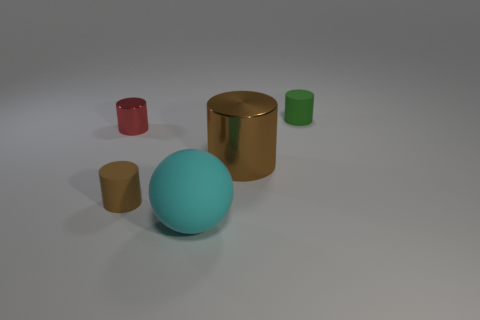Subtract all brown balls. Subtract all gray blocks. How many balls are left? 1 Add 4 large rubber balls. How many objects exist? 9 Subtract all cylinders. How many objects are left? 1 Subtract 2 brown cylinders. How many objects are left? 3 Subtract all red matte balls. Subtract all big metal cylinders. How many objects are left? 4 Add 5 green cylinders. How many green cylinders are left? 6 Add 4 large yellow matte spheres. How many large yellow matte spheres exist? 4 